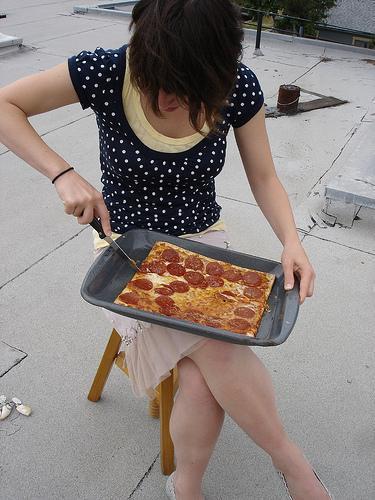How many people are shown?
Give a very brief answer. 1. 